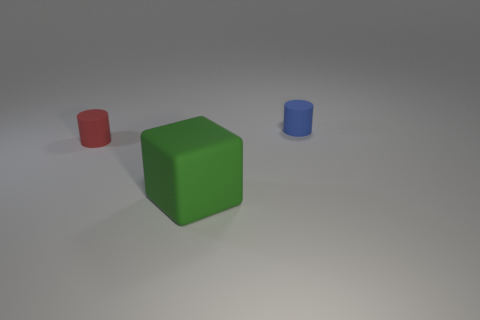How many tiny balls are made of the same material as the tiny red cylinder?
Your response must be concise. 0. What number of metallic things are either green cubes or tiny green cylinders?
Your response must be concise. 0. Is the shape of the tiny thing that is in front of the blue cylinder the same as the tiny thing that is to the right of the green block?
Keep it short and to the point. Yes. What is the color of the thing that is behind the big block and on the right side of the red thing?
Your answer should be compact. Blue. There is a object that is behind the tiny red thing; does it have the same size as the green object that is to the right of the red object?
Your answer should be compact. No. How many cubes are the same color as the large rubber thing?
Offer a terse response. 0. How many small things are red shiny blocks or green things?
Make the answer very short. 0. There is a matte object that is on the left side of the large rubber object; what is its color?
Make the answer very short. Red. Are there any blue things that have the same size as the red matte object?
Offer a terse response. Yes. There is a blue cylinder that is the same size as the red object; what material is it?
Offer a very short reply. Rubber. 